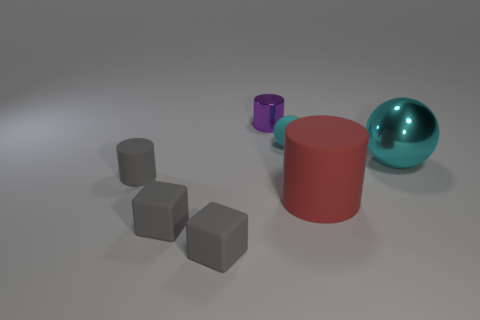Are there more small gray rubber things than metallic cylinders?
Offer a very short reply. Yes. What size is the red rubber object that is the same shape as the tiny metallic thing?
Your response must be concise. Large. Does the tiny sphere have the same material as the big object that is left of the large cyan shiny thing?
Give a very brief answer. Yes. What number of things are either tiny cyan objects or blue objects?
Provide a succinct answer. 1. Is the size of the shiny cylinder to the left of the shiny sphere the same as the cyan thing that is to the left of the cyan shiny object?
Keep it short and to the point. Yes. How many cubes are either metallic objects or red objects?
Provide a short and direct response. 0. Are any big red rubber cylinders visible?
Provide a succinct answer. Yes. Is there any other thing that is the same shape as the small purple metal thing?
Offer a terse response. Yes. Does the tiny rubber ball have the same color as the big metallic thing?
Make the answer very short. Yes. How many things are either spheres that are on the left side of the large red cylinder or gray matte cylinders?
Your response must be concise. 2. 